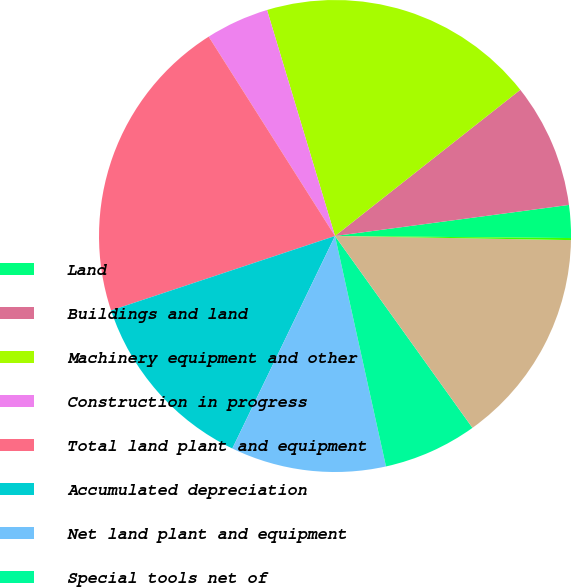Convert chart. <chart><loc_0><loc_0><loc_500><loc_500><pie_chart><fcel>Land<fcel>Buildings and land<fcel>Machinery equipment and other<fcel>Construction in progress<fcel>Total land plant and equipment<fcel>Accumulated depreciation<fcel>Net land plant and equipment<fcel>Special tools net of<fcel>Net Automotive Sector property<fcel>Net Financial Services Sector<nl><fcel>2.24%<fcel>8.53%<fcel>19.02%<fcel>4.34%<fcel>21.12%<fcel>12.73%<fcel>10.63%<fcel>6.43%<fcel>14.83%<fcel>0.14%<nl></chart> 